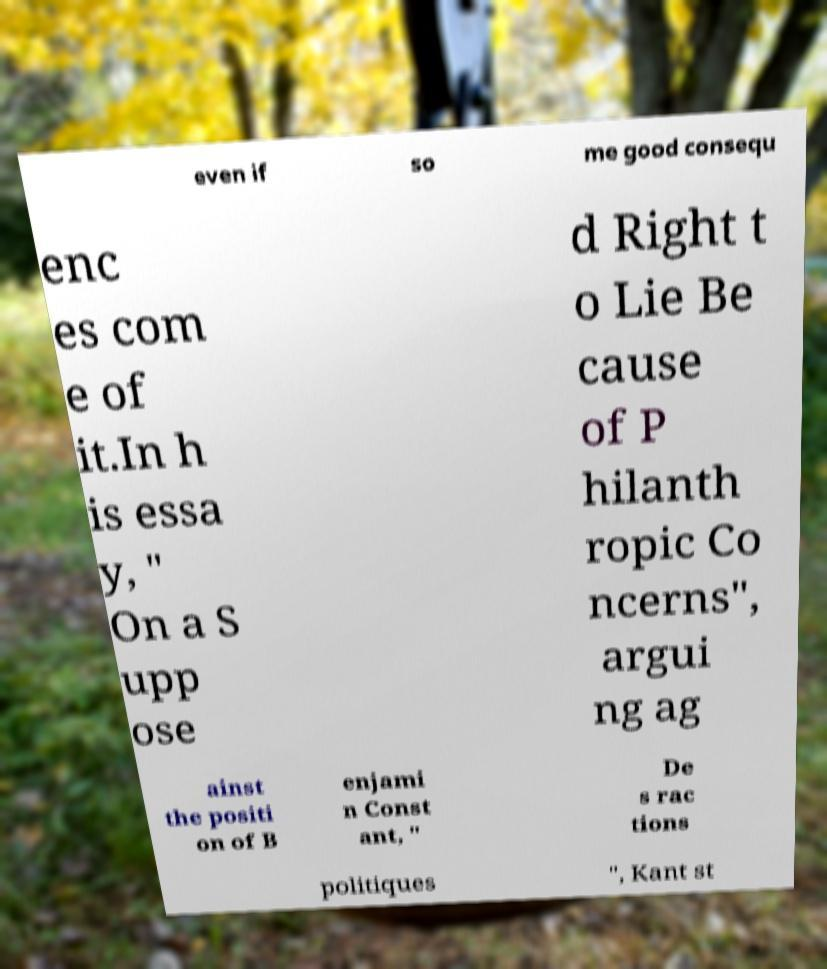Can you accurately transcribe the text from the provided image for me? even if so me good consequ enc es com e of it.In h is essa y, " On a S upp ose d Right t o Lie Be cause of P hilanth ropic Co ncerns", argui ng ag ainst the positi on of B enjami n Const ant, " De s rac tions politiques ", Kant st 